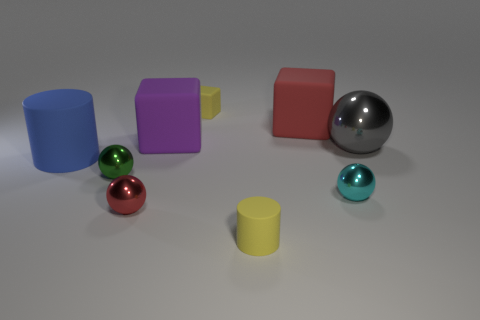Add 1 big green matte cubes. How many objects exist? 10 Subtract all blocks. How many objects are left? 6 Subtract all big purple metallic cubes. Subtract all large blue cylinders. How many objects are left? 8 Add 2 tiny yellow cylinders. How many tiny yellow cylinders are left? 3 Add 1 small rubber blocks. How many small rubber blocks exist? 2 Subtract 0 purple balls. How many objects are left? 9 